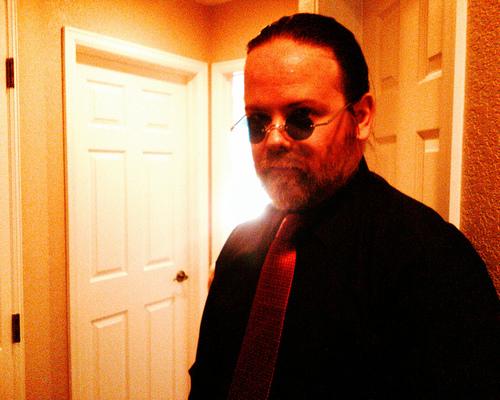Is the man in a setting where you'd normally wear sunglasses?
Short answer required. No. What kind of glasses is this man wearing?
Quick response, please. Sunglasses. Is the door behind this person open?
Write a very short answer. No. 